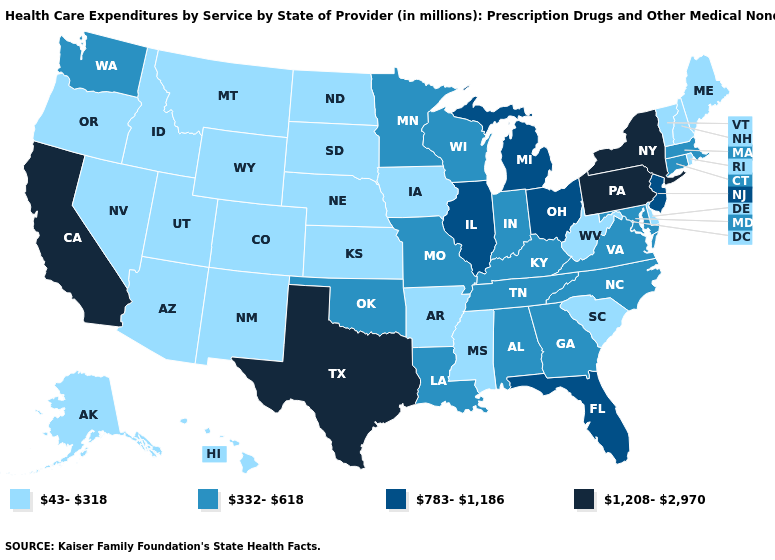What is the highest value in the USA?
Keep it brief. 1,208-2,970. What is the lowest value in the Northeast?
Be succinct. 43-318. Does the first symbol in the legend represent the smallest category?
Quick response, please. Yes. Name the states that have a value in the range 332-618?
Quick response, please. Alabama, Connecticut, Georgia, Indiana, Kentucky, Louisiana, Maryland, Massachusetts, Minnesota, Missouri, North Carolina, Oklahoma, Tennessee, Virginia, Washington, Wisconsin. Which states hav the highest value in the Northeast?
Answer briefly. New York, Pennsylvania. What is the highest value in the USA?
Quick response, please. 1,208-2,970. What is the value of Iowa?
Keep it brief. 43-318. How many symbols are there in the legend?
Concise answer only. 4. What is the value of Illinois?
Keep it brief. 783-1,186. What is the lowest value in the West?
Quick response, please. 43-318. How many symbols are there in the legend?
Be succinct. 4. Which states have the lowest value in the South?
Quick response, please. Arkansas, Delaware, Mississippi, South Carolina, West Virginia. How many symbols are there in the legend?
Short answer required. 4. Name the states that have a value in the range 783-1,186?
Answer briefly. Florida, Illinois, Michigan, New Jersey, Ohio. 